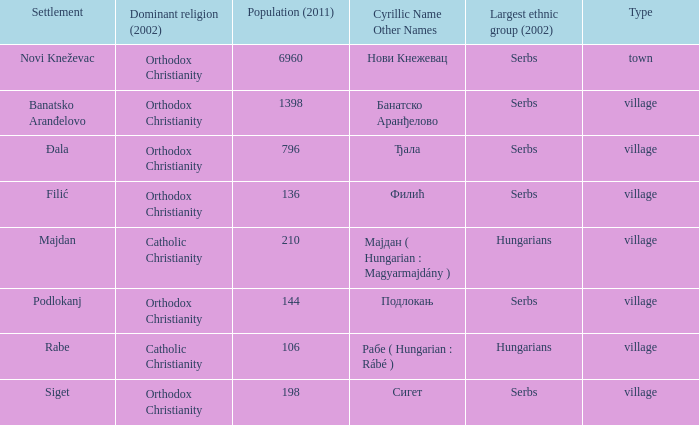What is the cyrillic and other name of rabe? Рабе ( Hungarian : Rábé ). 